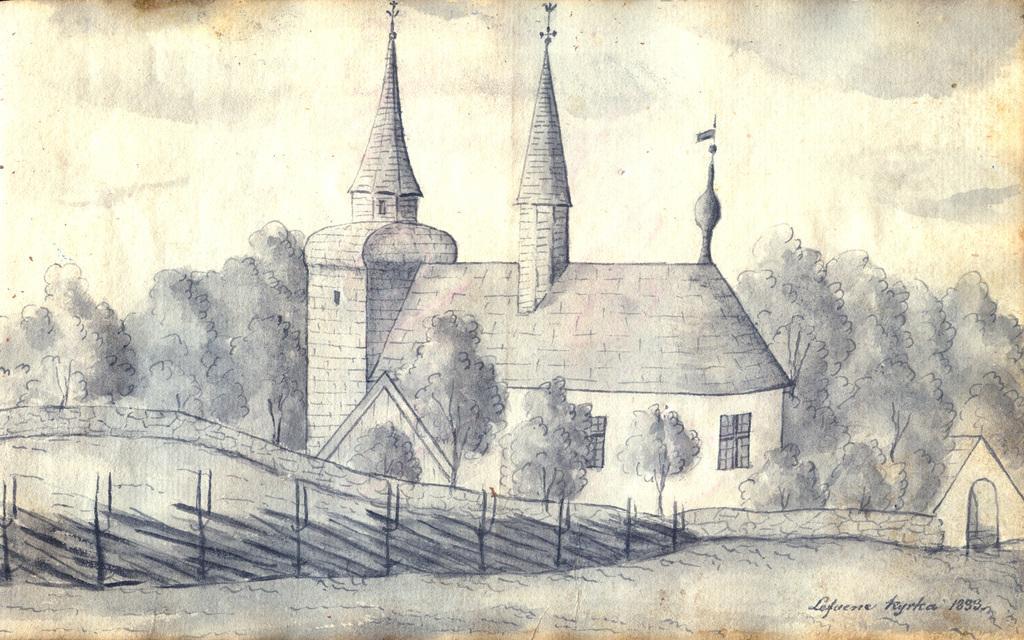Describe this image in one or two sentences. In this image we can see a drawing of a building with windows, some trees around it, plants and the sky which looks cloudy. 